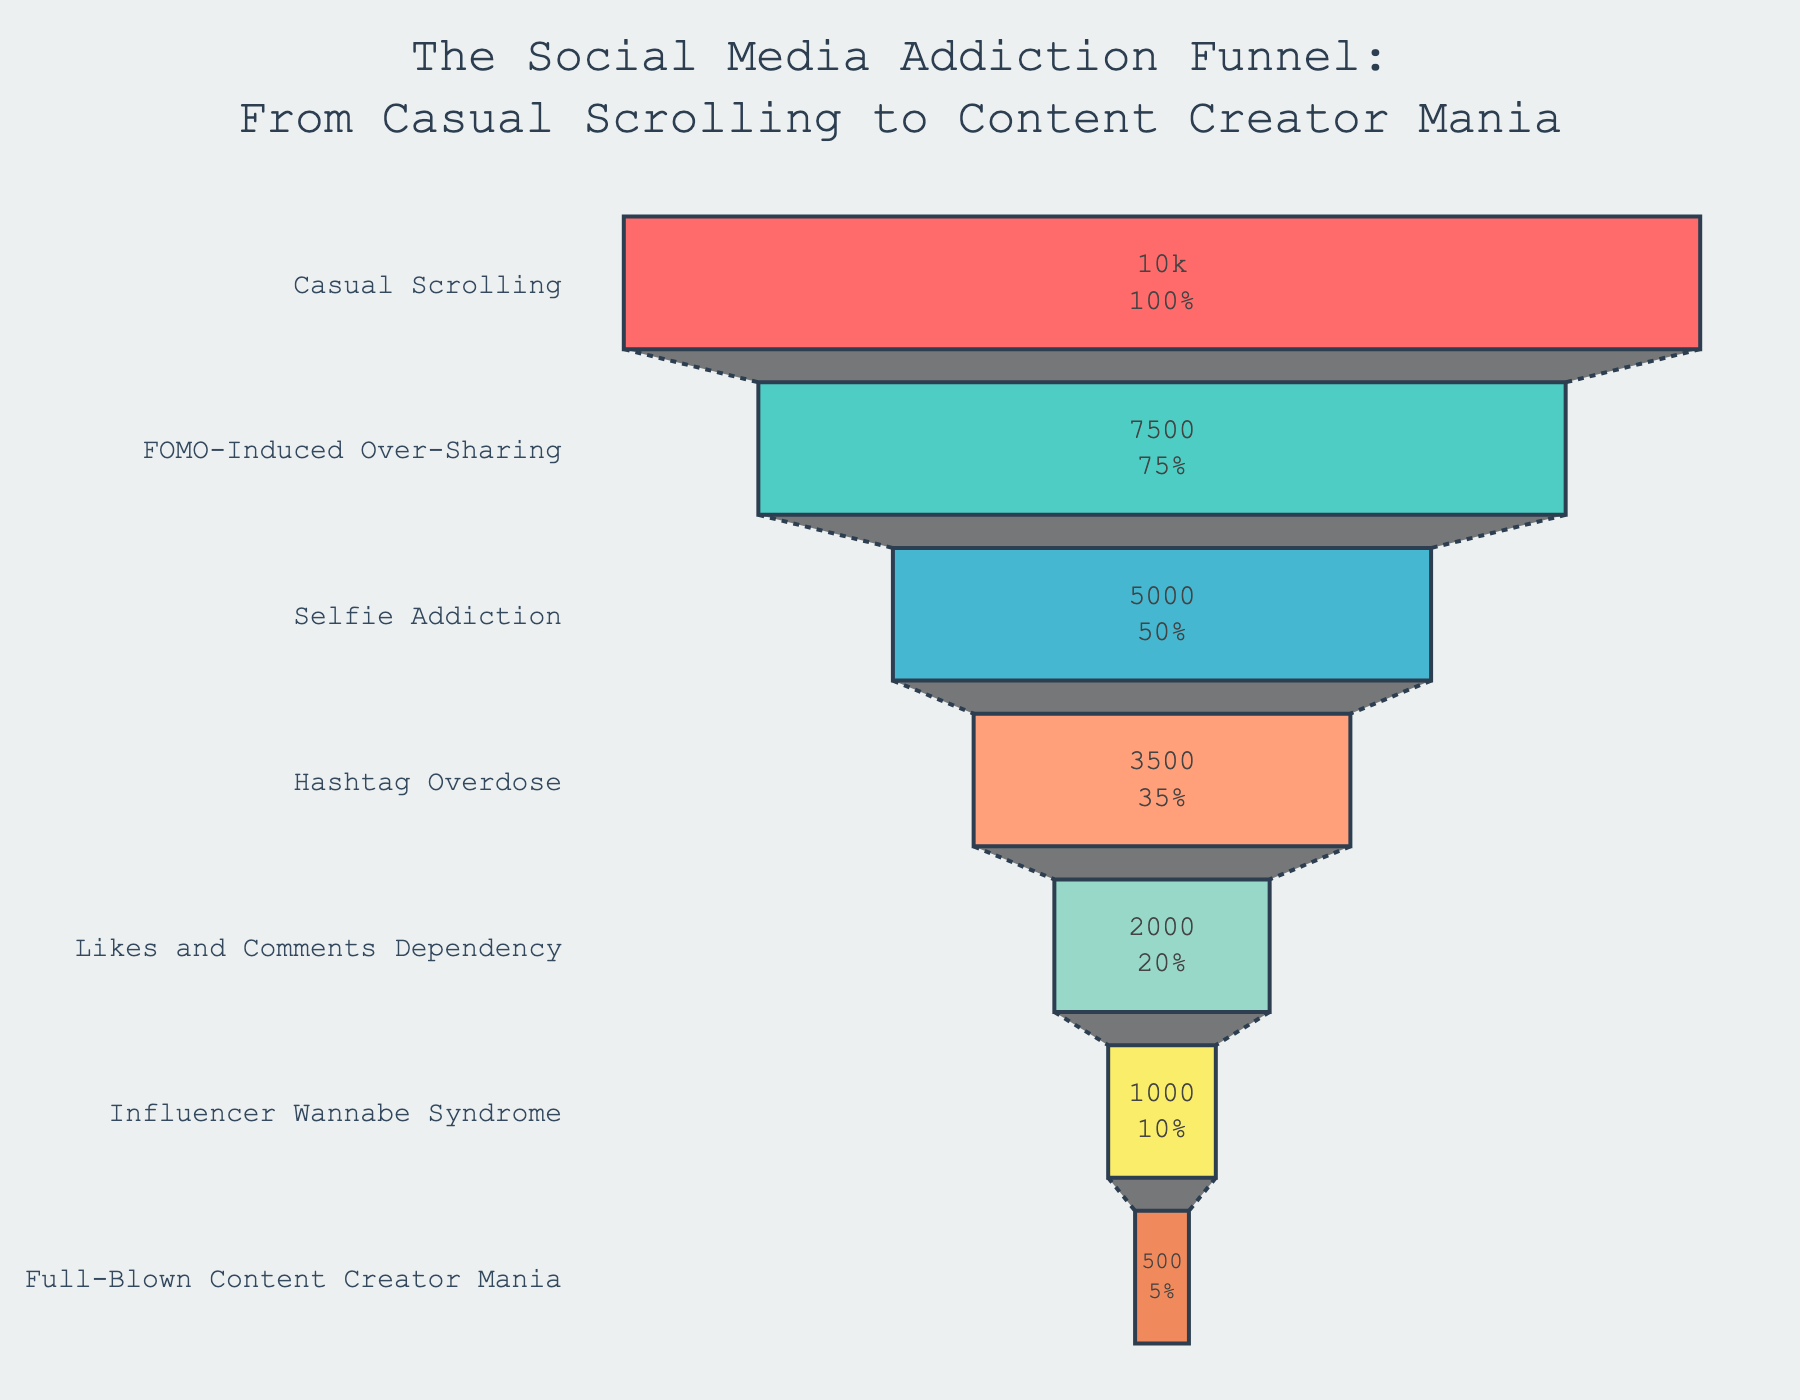What's the title of the funnel chart? The title is usually located at the top of the chart, displaying the overall topic being visualized.
Answer: The Social Media Addiction Funnel: From Casual Scrolling to Content Creator Mania How many stages are represented in the funnel chart? Each stage is a distinct level in the funnel. By counting all levels, we get the total number of stages.
Answer: 7 Which stage has the highest number of users? The stage with the highest number of users is typically the first stage at the top of the funnel.
Answer: Casual Scrolling What color represents the stage named "Likes and Comments Dependency"? We look for the corresponding colored bar next to the "Likes and Comments Dependency" label to identify its color.
Answer: Light green How many users are lost between the "Casual Scrolling" and "Selfie Addiction" stages? Subtract the number of users in the "Selfie Addiction" stage from the number of users in the "Casual Scrolling" stage.
Answer: 10000 - 5000 = 5000 What percent of users move on from "FOMO-Induced Over-Sharing" to "Selfie Addiction"? This requires calculating the percentage of "Selfie Addiction" users out of "FOMO-Induced Over-Sharing" users.
Answer: (5000 / 7500) * 100 = 66.67% Which stage has fewer users: "Hashtag Overdose" or "Influencer Wannabe Syndrome"? Compare the user counts of both stages to determine which has fewer users.
Answer: Influencer Wannabe Syndrome How many more users are there in "Hashtag Overdose" compared to "Likes and Comments Dependency"? Subtract the number of users in "Likes and Comments Dependency" from the number of users in "Hashtag Overdose".
Answer: 3500 - 2000 = 1500 What is the cumulative number of users from the two least populated stages? Sum the number of users in "Full-Blown Content Creator Mania" and "Influencer Wannabe Syndrome".
Answer: 500 + 1000 = 1500 What annotation is included at the bottom of the chart? Annotations typically provide additional insights or cautionary notes and are often found close to the chart's footer.
Answer: Caution: Side effects may include excessive emoji use and uncontrollable hashtag outbursts 